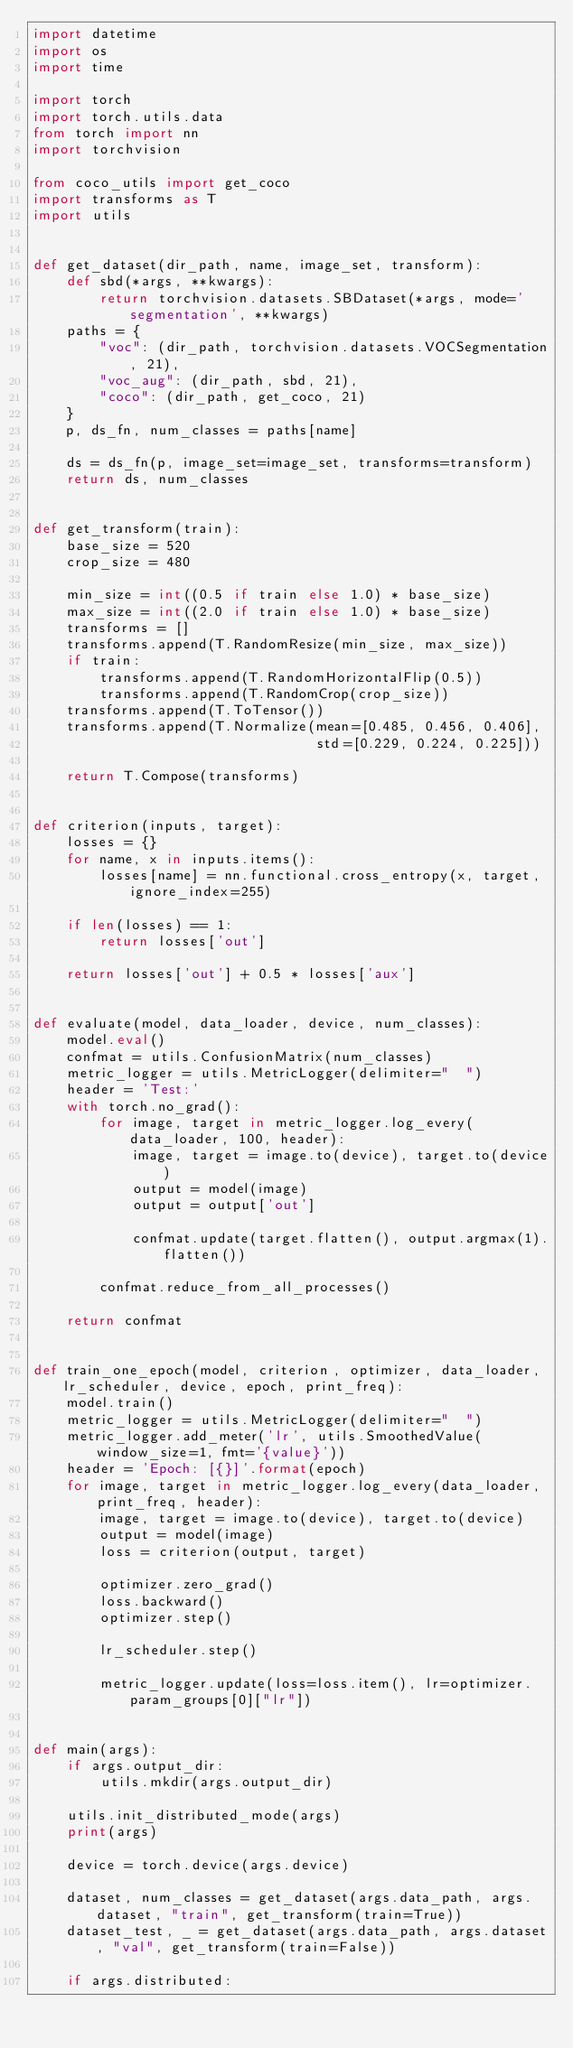<code> <loc_0><loc_0><loc_500><loc_500><_Python_>import datetime
import os
import time

import torch
import torch.utils.data
from torch import nn
import torchvision

from coco_utils import get_coco
import transforms as T
import utils


def get_dataset(dir_path, name, image_set, transform):
    def sbd(*args, **kwargs):
        return torchvision.datasets.SBDataset(*args, mode='segmentation', **kwargs)
    paths = {
        "voc": (dir_path, torchvision.datasets.VOCSegmentation, 21),
        "voc_aug": (dir_path, sbd, 21),
        "coco": (dir_path, get_coco, 21)
    }
    p, ds_fn, num_classes = paths[name]

    ds = ds_fn(p, image_set=image_set, transforms=transform)
    return ds, num_classes


def get_transform(train):
    base_size = 520
    crop_size = 480

    min_size = int((0.5 if train else 1.0) * base_size)
    max_size = int((2.0 if train else 1.0) * base_size)
    transforms = []
    transforms.append(T.RandomResize(min_size, max_size))
    if train:
        transforms.append(T.RandomHorizontalFlip(0.5))
        transforms.append(T.RandomCrop(crop_size))
    transforms.append(T.ToTensor())
    transforms.append(T.Normalize(mean=[0.485, 0.456, 0.406],
                                  std=[0.229, 0.224, 0.225]))

    return T.Compose(transforms)


def criterion(inputs, target):
    losses = {}
    for name, x in inputs.items():
        losses[name] = nn.functional.cross_entropy(x, target, ignore_index=255)

    if len(losses) == 1:
        return losses['out']

    return losses['out'] + 0.5 * losses['aux']


def evaluate(model, data_loader, device, num_classes):
    model.eval()
    confmat = utils.ConfusionMatrix(num_classes)
    metric_logger = utils.MetricLogger(delimiter="  ")
    header = 'Test:'
    with torch.no_grad():
        for image, target in metric_logger.log_every(data_loader, 100, header):
            image, target = image.to(device), target.to(device)
            output = model(image)
            output = output['out']

            confmat.update(target.flatten(), output.argmax(1).flatten())

        confmat.reduce_from_all_processes()

    return confmat


def train_one_epoch(model, criterion, optimizer, data_loader, lr_scheduler, device, epoch, print_freq):
    model.train()
    metric_logger = utils.MetricLogger(delimiter="  ")
    metric_logger.add_meter('lr', utils.SmoothedValue(window_size=1, fmt='{value}'))
    header = 'Epoch: [{}]'.format(epoch)
    for image, target in metric_logger.log_every(data_loader, print_freq, header):
        image, target = image.to(device), target.to(device)
        output = model(image)
        loss = criterion(output, target)

        optimizer.zero_grad()
        loss.backward()
        optimizer.step()

        lr_scheduler.step()

        metric_logger.update(loss=loss.item(), lr=optimizer.param_groups[0]["lr"])


def main(args):
    if args.output_dir:
        utils.mkdir(args.output_dir)

    utils.init_distributed_mode(args)
    print(args)

    device = torch.device(args.device)

    dataset, num_classes = get_dataset(args.data_path, args.dataset, "train", get_transform(train=True))
    dataset_test, _ = get_dataset(args.data_path, args.dataset, "val", get_transform(train=False))

    if args.distributed:</code> 